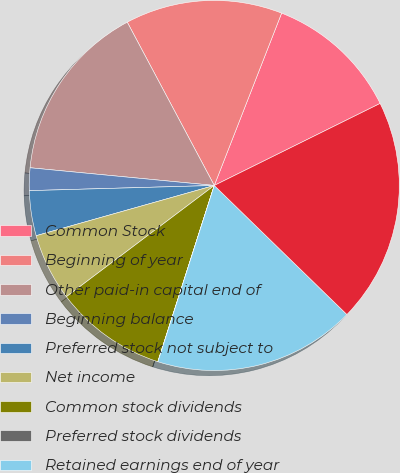Convert chart to OTSL. <chart><loc_0><loc_0><loc_500><loc_500><pie_chart><fcel>Common Stock<fcel>Beginning of year<fcel>Other paid-in capital end of<fcel>Beginning balance<fcel>Preferred stock not subject to<fcel>Net income<fcel>Common stock dividends<fcel>Preferred stock dividends<fcel>Retained earnings end of year<fcel>Total Stockholders' Equity<nl><fcel>11.76%<fcel>13.72%<fcel>15.68%<fcel>1.97%<fcel>3.93%<fcel>5.89%<fcel>9.8%<fcel>0.01%<fcel>17.64%<fcel>19.59%<nl></chart> 